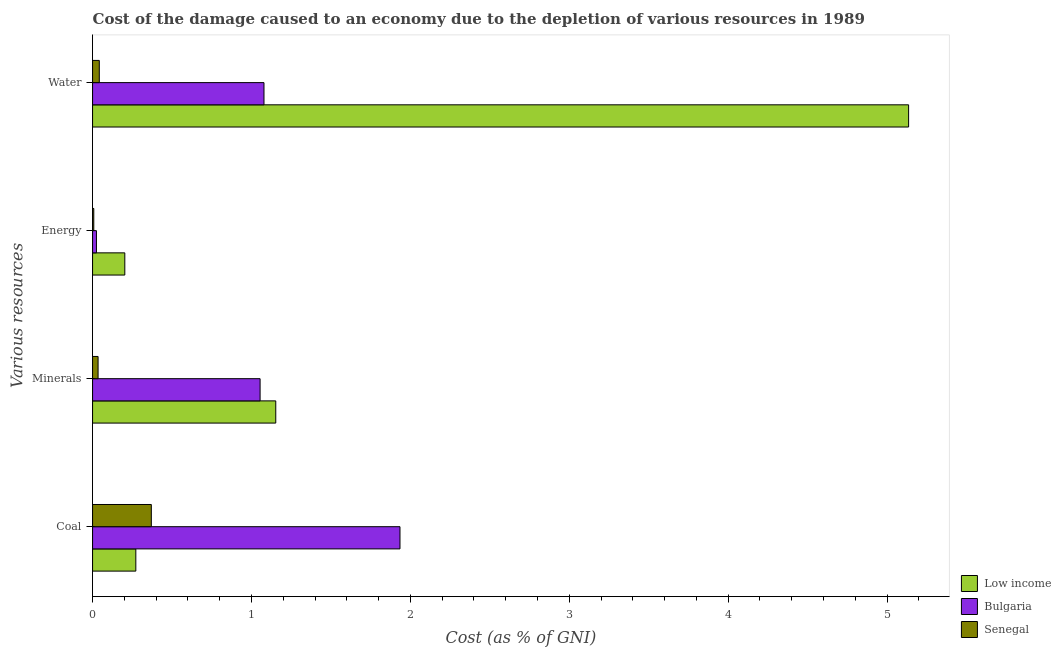How many groups of bars are there?
Provide a short and direct response. 4. Are the number of bars on each tick of the Y-axis equal?
Offer a terse response. Yes. How many bars are there on the 1st tick from the top?
Give a very brief answer. 3. What is the label of the 4th group of bars from the top?
Ensure brevity in your answer.  Coal. What is the cost of damage due to depletion of coal in Low income?
Offer a very short reply. 0.27. Across all countries, what is the maximum cost of damage due to depletion of minerals?
Give a very brief answer. 1.15. Across all countries, what is the minimum cost of damage due to depletion of minerals?
Provide a short and direct response. 0.03. In which country was the cost of damage due to depletion of minerals maximum?
Your response must be concise. Low income. In which country was the cost of damage due to depletion of energy minimum?
Offer a very short reply. Senegal. What is the total cost of damage due to depletion of energy in the graph?
Your answer should be compact. 0.23. What is the difference between the cost of damage due to depletion of coal in Bulgaria and that in Low income?
Your answer should be very brief. 1.66. What is the difference between the cost of damage due to depletion of minerals in Senegal and the cost of damage due to depletion of energy in Bulgaria?
Offer a very short reply. 0.01. What is the average cost of damage due to depletion of water per country?
Ensure brevity in your answer.  2.09. What is the difference between the cost of damage due to depletion of minerals and cost of damage due to depletion of energy in Senegal?
Your answer should be compact. 0.03. In how many countries, is the cost of damage due to depletion of coal greater than 4.6 %?
Make the answer very short. 0. What is the ratio of the cost of damage due to depletion of water in Senegal to that in Low income?
Offer a terse response. 0.01. Is the difference between the cost of damage due to depletion of minerals in Senegal and Low income greater than the difference between the cost of damage due to depletion of energy in Senegal and Low income?
Offer a very short reply. No. What is the difference between the highest and the second highest cost of damage due to depletion of energy?
Provide a succinct answer. 0.18. What is the difference between the highest and the lowest cost of damage due to depletion of water?
Provide a succinct answer. 5.09. Is the sum of the cost of damage due to depletion of water in Senegal and Low income greater than the maximum cost of damage due to depletion of minerals across all countries?
Make the answer very short. Yes. Is it the case that in every country, the sum of the cost of damage due to depletion of coal and cost of damage due to depletion of minerals is greater than the sum of cost of damage due to depletion of energy and cost of damage due to depletion of water?
Keep it short and to the point. Yes. Is it the case that in every country, the sum of the cost of damage due to depletion of coal and cost of damage due to depletion of minerals is greater than the cost of damage due to depletion of energy?
Provide a short and direct response. Yes. How many bars are there?
Your response must be concise. 12. Are all the bars in the graph horizontal?
Make the answer very short. Yes. Does the graph contain any zero values?
Offer a terse response. No. Does the graph contain grids?
Ensure brevity in your answer.  No. Where does the legend appear in the graph?
Provide a succinct answer. Bottom right. What is the title of the graph?
Your answer should be very brief. Cost of the damage caused to an economy due to the depletion of various resources in 1989 . Does "New Caledonia" appear as one of the legend labels in the graph?
Provide a succinct answer. No. What is the label or title of the X-axis?
Your answer should be very brief. Cost (as % of GNI). What is the label or title of the Y-axis?
Your answer should be very brief. Various resources. What is the Cost (as % of GNI) in Low income in Coal?
Offer a terse response. 0.27. What is the Cost (as % of GNI) in Bulgaria in Coal?
Offer a terse response. 1.93. What is the Cost (as % of GNI) in Senegal in Coal?
Your answer should be compact. 0.37. What is the Cost (as % of GNI) in Low income in Minerals?
Make the answer very short. 1.15. What is the Cost (as % of GNI) in Bulgaria in Minerals?
Keep it short and to the point. 1.05. What is the Cost (as % of GNI) in Senegal in Minerals?
Make the answer very short. 0.03. What is the Cost (as % of GNI) in Low income in Energy?
Your response must be concise. 0.2. What is the Cost (as % of GNI) of Bulgaria in Energy?
Offer a terse response. 0.02. What is the Cost (as % of GNI) of Senegal in Energy?
Provide a short and direct response. 0.01. What is the Cost (as % of GNI) of Low income in Water?
Provide a succinct answer. 5.14. What is the Cost (as % of GNI) of Bulgaria in Water?
Your answer should be very brief. 1.08. What is the Cost (as % of GNI) in Senegal in Water?
Provide a short and direct response. 0.04. Across all Various resources, what is the maximum Cost (as % of GNI) of Low income?
Offer a very short reply. 5.14. Across all Various resources, what is the maximum Cost (as % of GNI) of Bulgaria?
Offer a very short reply. 1.93. Across all Various resources, what is the maximum Cost (as % of GNI) of Senegal?
Keep it short and to the point. 0.37. Across all Various resources, what is the minimum Cost (as % of GNI) in Low income?
Make the answer very short. 0.2. Across all Various resources, what is the minimum Cost (as % of GNI) in Bulgaria?
Give a very brief answer. 0.02. Across all Various resources, what is the minimum Cost (as % of GNI) in Senegal?
Your answer should be very brief. 0.01. What is the total Cost (as % of GNI) in Low income in the graph?
Your answer should be compact. 6.76. What is the total Cost (as % of GNI) in Bulgaria in the graph?
Ensure brevity in your answer.  4.09. What is the total Cost (as % of GNI) of Senegal in the graph?
Provide a short and direct response. 0.45. What is the difference between the Cost (as % of GNI) in Low income in Coal and that in Minerals?
Offer a very short reply. -0.88. What is the difference between the Cost (as % of GNI) of Bulgaria in Coal and that in Minerals?
Keep it short and to the point. 0.88. What is the difference between the Cost (as % of GNI) of Senegal in Coal and that in Minerals?
Make the answer very short. 0.34. What is the difference between the Cost (as % of GNI) in Low income in Coal and that in Energy?
Offer a terse response. 0.07. What is the difference between the Cost (as % of GNI) in Bulgaria in Coal and that in Energy?
Provide a short and direct response. 1.91. What is the difference between the Cost (as % of GNI) of Senegal in Coal and that in Energy?
Ensure brevity in your answer.  0.36. What is the difference between the Cost (as % of GNI) of Low income in Coal and that in Water?
Your answer should be very brief. -4.86. What is the difference between the Cost (as % of GNI) in Bulgaria in Coal and that in Water?
Ensure brevity in your answer.  0.86. What is the difference between the Cost (as % of GNI) in Senegal in Coal and that in Water?
Offer a terse response. 0.33. What is the difference between the Cost (as % of GNI) in Low income in Minerals and that in Energy?
Keep it short and to the point. 0.95. What is the difference between the Cost (as % of GNI) in Bulgaria in Minerals and that in Energy?
Give a very brief answer. 1.03. What is the difference between the Cost (as % of GNI) of Senegal in Minerals and that in Energy?
Provide a succinct answer. 0.03. What is the difference between the Cost (as % of GNI) of Low income in Minerals and that in Water?
Give a very brief answer. -3.98. What is the difference between the Cost (as % of GNI) in Bulgaria in Minerals and that in Water?
Keep it short and to the point. -0.02. What is the difference between the Cost (as % of GNI) in Senegal in Minerals and that in Water?
Your response must be concise. -0.01. What is the difference between the Cost (as % of GNI) in Low income in Energy and that in Water?
Keep it short and to the point. -4.93. What is the difference between the Cost (as % of GNI) in Bulgaria in Energy and that in Water?
Provide a short and direct response. -1.05. What is the difference between the Cost (as % of GNI) in Senegal in Energy and that in Water?
Your response must be concise. -0.03. What is the difference between the Cost (as % of GNI) in Low income in Coal and the Cost (as % of GNI) in Bulgaria in Minerals?
Offer a very short reply. -0.78. What is the difference between the Cost (as % of GNI) in Low income in Coal and the Cost (as % of GNI) in Senegal in Minerals?
Offer a very short reply. 0.24. What is the difference between the Cost (as % of GNI) in Bulgaria in Coal and the Cost (as % of GNI) in Senegal in Minerals?
Your answer should be very brief. 1.9. What is the difference between the Cost (as % of GNI) of Low income in Coal and the Cost (as % of GNI) of Bulgaria in Energy?
Your answer should be compact. 0.25. What is the difference between the Cost (as % of GNI) of Low income in Coal and the Cost (as % of GNI) of Senegal in Energy?
Provide a short and direct response. 0.26. What is the difference between the Cost (as % of GNI) of Bulgaria in Coal and the Cost (as % of GNI) of Senegal in Energy?
Provide a succinct answer. 1.93. What is the difference between the Cost (as % of GNI) in Low income in Coal and the Cost (as % of GNI) in Bulgaria in Water?
Provide a short and direct response. -0.81. What is the difference between the Cost (as % of GNI) in Low income in Coal and the Cost (as % of GNI) in Senegal in Water?
Offer a terse response. 0.23. What is the difference between the Cost (as % of GNI) in Bulgaria in Coal and the Cost (as % of GNI) in Senegal in Water?
Your answer should be very brief. 1.89. What is the difference between the Cost (as % of GNI) of Low income in Minerals and the Cost (as % of GNI) of Bulgaria in Energy?
Your answer should be very brief. 1.13. What is the difference between the Cost (as % of GNI) in Low income in Minerals and the Cost (as % of GNI) in Senegal in Energy?
Provide a succinct answer. 1.15. What is the difference between the Cost (as % of GNI) in Bulgaria in Minerals and the Cost (as % of GNI) in Senegal in Energy?
Ensure brevity in your answer.  1.05. What is the difference between the Cost (as % of GNI) in Low income in Minerals and the Cost (as % of GNI) in Bulgaria in Water?
Offer a terse response. 0.07. What is the difference between the Cost (as % of GNI) in Low income in Minerals and the Cost (as % of GNI) in Senegal in Water?
Offer a terse response. 1.11. What is the difference between the Cost (as % of GNI) in Bulgaria in Minerals and the Cost (as % of GNI) in Senegal in Water?
Provide a short and direct response. 1.01. What is the difference between the Cost (as % of GNI) in Low income in Energy and the Cost (as % of GNI) in Bulgaria in Water?
Provide a succinct answer. -0.88. What is the difference between the Cost (as % of GNI) in Low income in Energy and the Cost (as % of GNI) in Senegal in Water?
Keep it short and to the point. 0.16. What is the difference between the Cost (as % of GNI) in Bulgaria in Energy and the Cost (as % of GNI) in Senegal in Water?
Your answer should be very brief. -0.02. What is the average Cost (as % of GNI) in Low income per Various resources?
Make the answer very short. 1.69. What is the average Cost (as % of GNI) in Senegal per Various resources?
Make the answer very short. 0.11. What is the difference between the Cost (as % of GNI) in Low income and Cost (as % of GNI) in Bulgaria in Coal?
Make the answer very short. -1.66. What is the difference between the Cost (as % of GNI) in Low income and Cost (as % of GNI) in Senegal in Coal?
Provide a short and direct response. -0.1. What is the difference between the Cost (as % of GNI) of Bulgaria and Cost (as % of GNI) of Senegal in Coal?
Ensure brevity in your answer.  1.56. What is the difference between the Cost (as % of GNI) in Low income and Cost (as % of GNI) in Bulgaria in Minerals?
Provide a short and direct response. 0.1. What is the difference between the Cost (as % of GNI) of Low income and Cost (as % of GNI) of Senegal in Minerals?
Give a very brief answer. 1.12. What is the difference between the Cost (as % of GNI) in Bulgaria and Cost (as % of GNI) in Senegal in Minerals?
Provide a succinct answer. 1.02. What is the difference between the Cost (as % of GNI) in Low income and Cost (as % of GNI) in Bulgaria in Energy?
Keep it short and to the point. 0.18. What is the difference between the Cost (as % of GNI) in Low income and Cost (as % of GNI) in Senegal in Energy?
Provide a succinct answer. 0.2. What is the difference between the Cost (as % of GNI) in Bulgaria and Cost (as % of GNI) in Senegal in Energy?
Make the answer very short. 0.02. What is the difference between the Cost (as % of GNI) in Low income and Cost (as % of GNI) in Bulgaria in Water?
Give a very brief answer. 4.06. What is the difference between the Cost (as % of GNI) in Low income and Cost (as % of GNI) in Senegal in Water?
Keep it short and to the point. 5.09. What is the difference between the Cost (as % of GNI) in Bulgaria and Cost (as % of GNI) in Senegal in Water?
Your answer should be very brief. 1.04. What is the ratio of the Cost (as % of GNI) of Low income in Coal to that in Minerals?
Make the answer very short. 0.24. What is the ratio of the Cost (as % of GNI) in Bulgaria in Coal to that in Minerals?
Offer a terse response. 1.84. What is the ratio of the Cost (as % of GNI) of Senegal in Coal to that in Minerals?
Ensure brevity in your answer.  10.66. What is the ratio of the Cost (as % of GNI) of Low income in Coal to that in Energy?
Provide a short and direct response. 1.34. What is the ratio of the Cost (as % of GNI) in Bulgaria in Coal to that in Energy?
Make the answer very short. 79.03. What is the ratio of the Cost (as % of GNI) in Senegal in Coal to that in Energy?
Provide a short and direct response. 48.54. What is the ratio of the Cost (as % of GNI) of Low income in Coal to that in Water?
Offer a terse response. 0.05. What is the ratio of the Cost (as % of GNI) of Bulgaria in Coal to that in Water?
Give a very brief answer. 1.79. What is the ratio of the Cost (as % of GNI) in Senegal in Coal to that in Water?
Make the answer very short. 8.74. What is the ratio of the Cost (as % of GNI) of Low income in Minerals to that in Energy?
Your answer should be compact. 5.68. What is the ratio of the Cost (as % of GNI) in Bulgaria in Minerals to that in Energy?
Give a very brief answer. 43.07. What is the ratio of the Cost (as % of GNI) of Senegal in Minerals to that in Energy?
Your answer should be compact. 4.56. What is the ratio of the Cost (as % of GNI) in Low income in Minerals to that in Water?
Your answer should be very brief. 0.22. What is the ratio of the Cost (as % of GNI) of Bulgaria in Minerals to that in Water?
Provide a succinct answer. 0.98. What is the ratio of the Cost (as % of GNI) of Senegal in Minerals to that in Water?
Your answer should be very brief. 0.82. What is the ratio of the Cost (as % of GNI) of Low income in Energy to that in Water?
Give a very brief answer. 0.04. What is the ratio of the Cost (as % of GNI) in Bulgaria in Energy to that in Water?
Your answer should be compact. 0.02. What is the ratio of the Cost (as % of GNI) of Senegal in Energy to that in Water?
Keep it short and to the point. 0.18. What is the difference between the highest and the second highest Cost (as % of GNI) in Low income?
Ensure brevity in your answer.  3.98. What is the difference between the highest and the second highest Cost (as % of GNI) in Bulgaria?
Keep it short and to the point. 0.86. What is the difference between the highest and the second highest Cost (as % of GNI) in Senegal?
Provide a short and direct response. 0.33. What is the difference between the highest and the lowest Cost (as % of GNI) in Low income?
Make the answer very short. 4.93. What is the difference between the highest and the lowest Cost (as % of GNI) of Bulgaria?
Make the answer very short. 1.91. What is the difference between the highest and the lowest Cost (as % of GNI) in Senegal?
Your response must be concise. 0.36. 